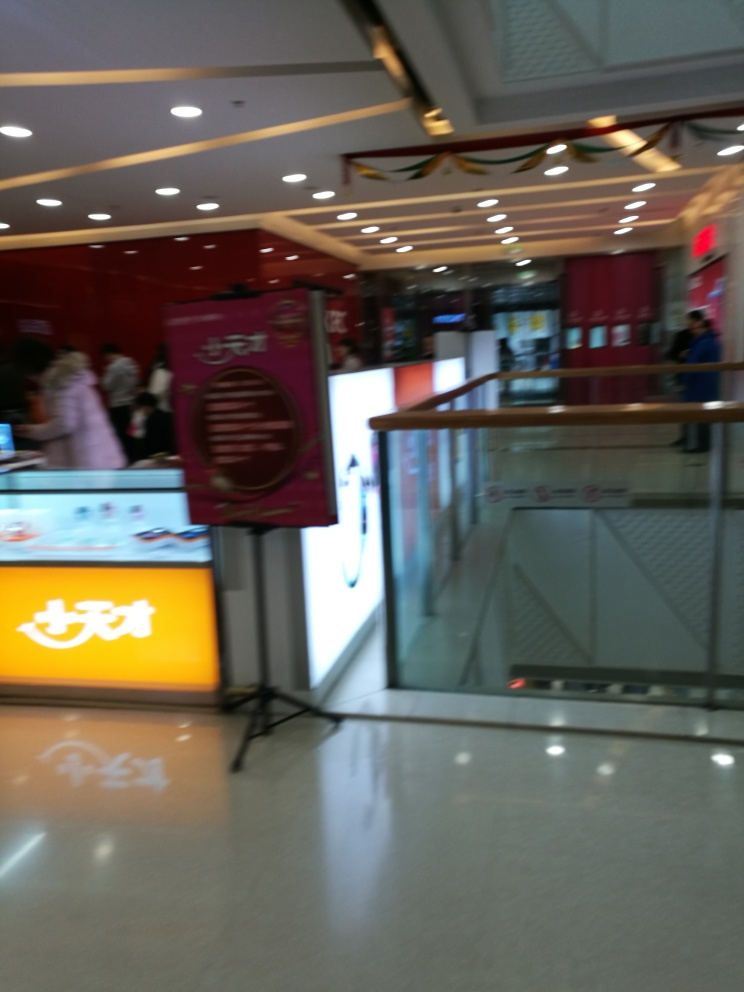What sort of businesses can you infer are present in this location? From the signage visible, despite the blurriness, there seems to be a variety of businesses, possibly including a food or beverage outlet indicated by the counters and menus, as well as likely retail or service-oriented stores. 